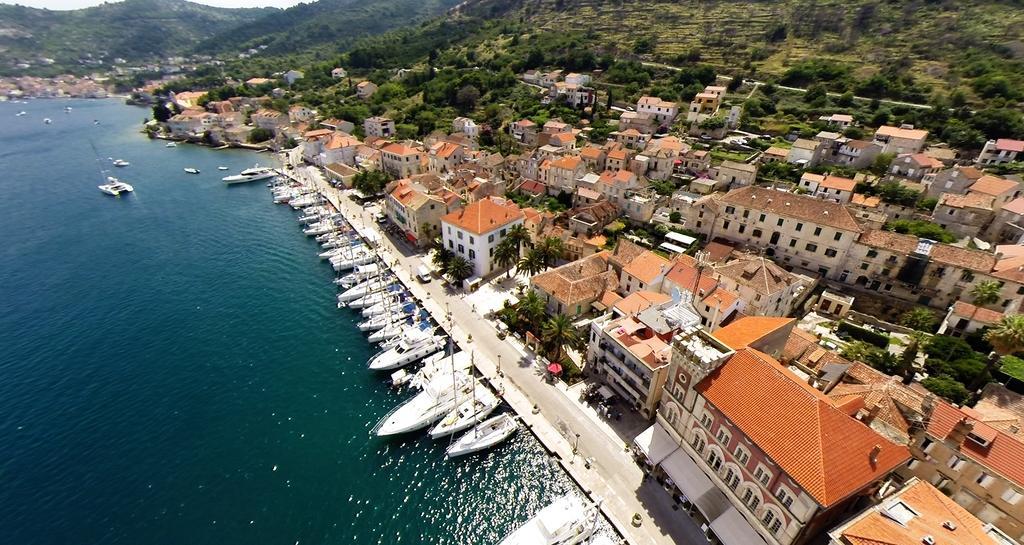How would you summarize this image in a sentence or two? In this picture we can see few boats on the water, beside the water we can see few buildings and trees, in the background we can see hills. 